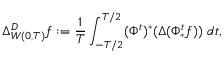<formula> <loc_0><loc_0><loc_500><loc_500>\Delta _ { W ( 0 , T ) } ^ { D } f \colon = \frac { 1 } { T } \int _ { - T / 2 } ^ { T / 2 } ( \Phi ^ { t } ) ^ { * } ( \Delta ( \Phi _ { * } ^ { t } f ) ) \ d t ,</formula> 